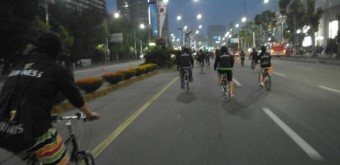Can you describe the setting of this image? Certainly, the image depicts a group of cyclists on an urban road. The presence of ample lane space, absence of traffic, and organized cycling suggest this might be during a cycling event or a time when the road is closed for recreational activities. 